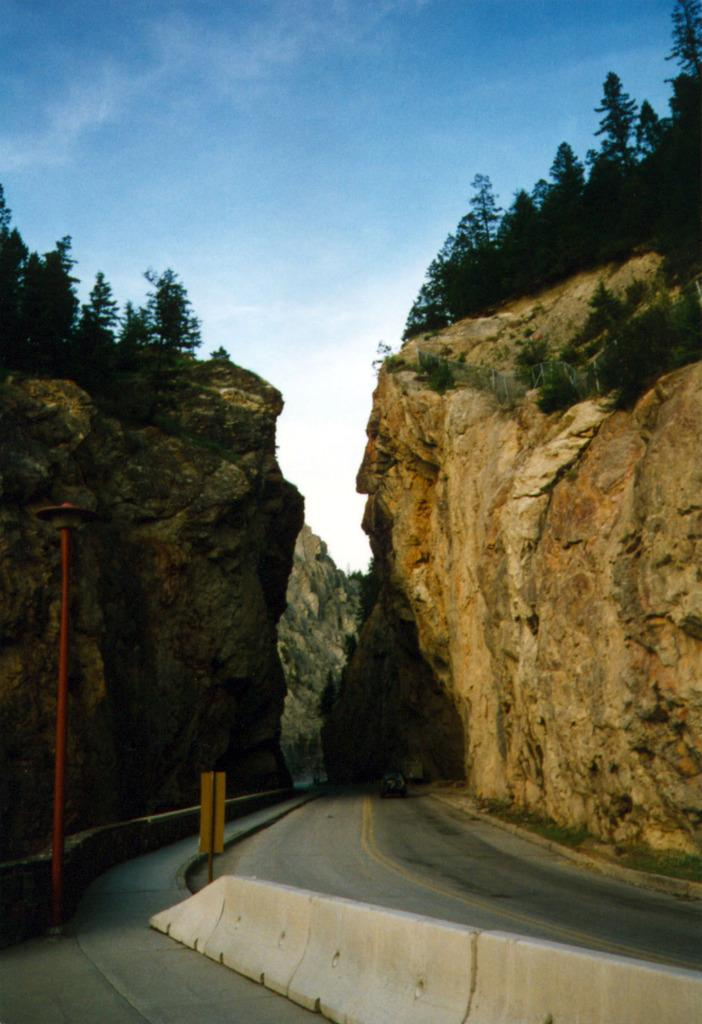What separates the areas in the image? There is a divider in the image. What can be seen running through the image? The road is present in the image. What is located at the bottom of the image? A pole is visible at the bottom of the image. What type of vegetation is visible in the background of the image? There are trees on the mountains in the background of the image. What is visible at the top of the image? The sky is visible at the top of the image. What type of cloth is draped over the divider in the image? There is no cloth present in the image; it only features a divider, road, pole, trees, and sky. What day of the week is depicted in the image? The image does not depict a specific day of the week; it is a still image without any time-related information. 